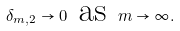<formula> <loc_0><loc_0><loc_500><loc_500>\delta _ { m , 2 } \rightarrow 0 \ \text {as} \ m \rightarrow \infty .</formula> 